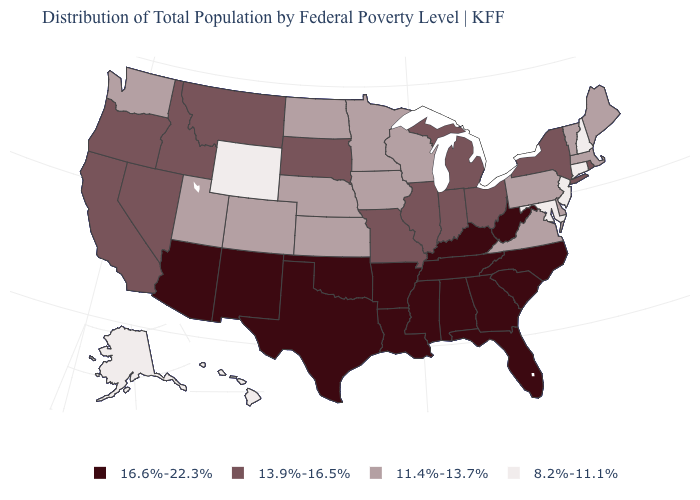Name the states that have a value in the range 8.2%-11.1%?
Write a very short answer. Alaska, Connecticut, Hawaii, Maryland, New Hampshire, New Jersey, Wyoming. Is the legend a continuous bar?
Answer briefly. No. Name the states that have a value in the range 8.2%-11.1%?
Be succinct. Alaska, Connecticut, Hawaii, Maryland, New Hampshire, New Jersey, Wyoming. Among the states that border North Carolina , does Virginia have the highest value?
Concise answer only. No. Does the map have missing data?
Quick response, please. No. What is the value of Oklahoma?
Write a very short answer. 16.6%-22.3%. Does Hawaii have the lowest value in the USA?
Be succinct. Yes. Name the states that have a value in the range 16.6%-22.3%?
Short answer required. Alabama, Arizona, Arkansas, Florida, Georgia, Kentucky, Louisiana, Mississippi, New Mexico, North Carolina, Oklahoma, South Carolina, Tennessee, Texas, West Virginia. Among the states that border West Virginia , does Ohio have the highest value?
Be succinct. No. Among the states that border North Dakota , which have the lowest value?
Write a very short answer. Minnesota. Does New Mexico have the highest value in the West?
Answer briefly. Yes. What is the value of Georgia?
Keep it brief. 16.6%-22.3%. What is the highest value in the USA?
Keep it brief. 16.6%-22.3%. Name the states that have a value in the range 16.6%-22.3%?
Short answer required. Alabama, Arizona, Arkansas, Florida, Georgia, Kentucky, Louisiana, Mississippi, New Mexico, North Carolina, Oklahoma, South Carolina, Tennessee, Texas, West Virginia. What is the value of Arizona?
Concise answer only. 16.6%-22.3%. 